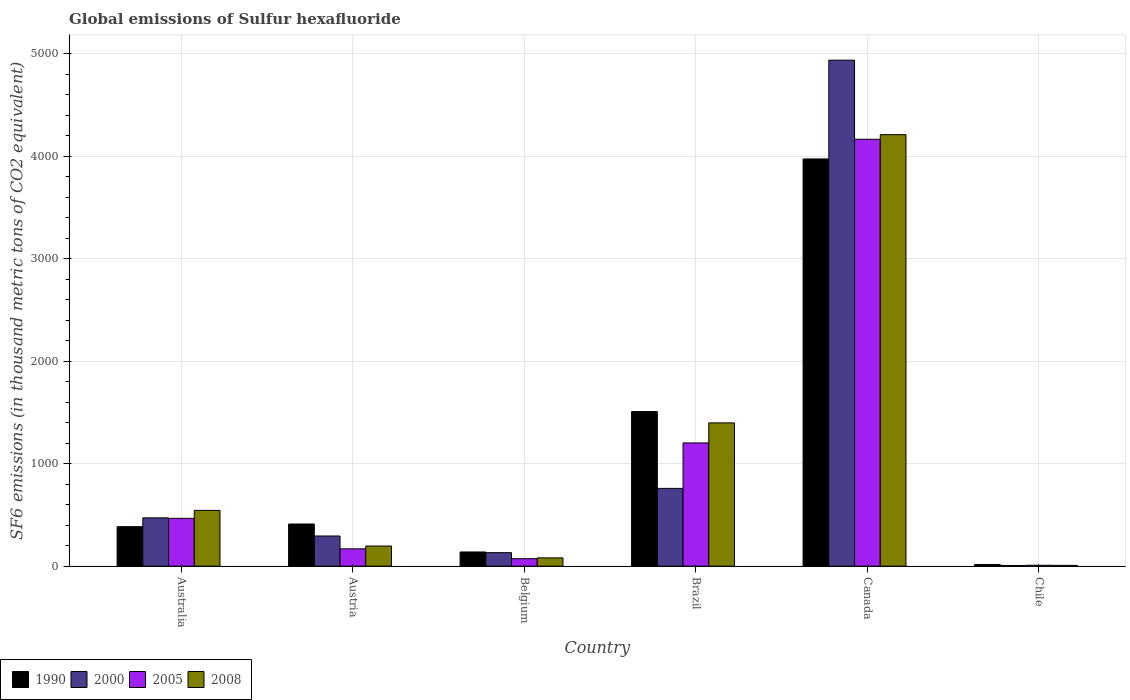How many groups of bars are there?
Offer a very short reply. 6. Are the number of bars per tick equal to the number of legend labels?
Your response must be concise. Yes. How many bars are there on the 6th tick from the left?
Make the answer very short. 4. How many bars are there on the 5th tick from the right?
Keep it short and to the point. 4. What is the label of the 1st group of bars from the left?
Provide a short and direct response. Australia. In how many cases, is the number of bars for a given country not equal to the number of legend labels?
Ensure brevity in your answer.  0. What is the global emissions of Sulfur hexafluoride in 2000 in Belgium?
Your response must be concise. 131.7. Across all countries, what is the maximum global emissions of Sulfur hexafluoride in 2008?
Give a very brief answer. 4208.8. In which country was the global emissions of Sulfur hexafluoride in 2008 maximum?
Provide a succinct answer. Canada. In which country was the global emissions of Sulfur hexafluoride in 2005 minimum?
Keep it short and to the point. Chile. What is the total global emissions of Sulfur hexafluoride in 2005 in the graph?
Your answer should be very brief. 6083.3. What is the difference between the global emissions of Sulfur hexafluoride in 1990 in Australia and that in Canada?
Provide a succinct answer. -3586.7. What is the difference between the global emissions of Sulfur hexafluoride in 1990 in Australia and the global emissions of Sulfur hexafluoride in 2000 in Chile?
Ensure brevity in your answer.  378.4. What is the average global emissions of Sulfur hexafluoride in 1990 per country?
Provide a succinct answer. 1071.83. What is the difference between the global emissions of Sulfur hexafluoride of/in 2008 and global emissions of Sulfur hexafluoride of/in 1990 in Brazil?
Give a very brief answer. -110.6. What is the ratio of the global emissions of Sulfur hexafluoride in 2000 in Australia to that in Brazil?
Offer a terse response. 0.62. What is the difference between the highest and the second highest global emissions of Sulfur hexafluoride in 1990?
Your response must be concise. 3560.6. What is the difference between the highest and the lowest global emissions of Sulfur hexafluoride in 2008?
Provide a succinct answer. 4200.9. In how many countries, is the global emissions of Sulfur hexafluoride in 2000 greater than the average global emissions of Sulfur hexafluoride in 2000 taken over all countries?
Your answer should be very brief. 1. Is it the case that in every country, the sum of the global emissions of Sulfur hexafluoride in 2008 and global emissions of Sulfur hexafluoride in 1990 is greater than the sum of global emissions of Sulfur hexafluoride in 2005 and global emissions of Sulfur hexafluoride in 2000?
Keep it short and to the point. No. What does the 4th bar from the right in Chile represents?
Your answer should be compact. 1990. How many bars are there?
Give a very brief answer. 24. Are all the bars in the graph horizontal?
Ensure brevity in your answer.  No. What is the difference between two consecutive major ticks on the Y-axis?
Offer a very short reply. 1000. Does the graph contain grids?
Your response must be concise. Yes. Where does the legend appear in the graph?
Your response must be concise. Bottom left. What is the title of the graph?
Keep it short and to the point. Global emissions of Sulfur hexafluoride. Does "1976" appear as one of the legend labels in the graph?
Make the answer very short. No. What is the label or title of the X-axis?
Ensure brevity in your answer.  Country. What is the label or title of the Y-axis?
Provide a succinct answer. SF6 emissions (in thousand metric tons of CO2 equivalent). What is the SF6 emissions (in thousand metric tons of CO2 equivalent) in 1990 in Australia?
Provide a short and direct response. 385.1. What is the SF6 emissions (in thousand metric tons of CO2 equivalent) in 2000 in Australia?
Your answer should be compact. 471.2. What is the SF6 emissions (in thousand metric tons of CO2 equivalent) of 2005 in Australia?
Offer a very short reply. 466.6. What is the SF6 emissions (in thousand metric tons of CO2 equivalent) of 2008 in Australia?
Your response must be concise. 544.1. What is the SF6 emissions (in thousand metric tons of CO2 equivalent) of 1990 in Austria?
Your response must be concise. 411.2. What is the SF6 emissions (in thousand metric tons of CO2 equivalent) in 2000 in Austria?
Your answer should be compact. 294.4. What is the SF6 emissions (in thousand metric tons of CO2 equivalent) of 2005 in Austria?
Your answer should be compact. 169. What is the SF6 emissions (in thousand metric tons of CO2 equivalent) of 2008 in Austria?
Keep it short and to the point. 196.4. What is the SF6 emissions (in thousand metric tons of CO2 equivalent) of 1990 in Belgium?
Keep it short and to the point. 138.5. What is the SF6 emissions (in thousand metric tons of CO2 equivalent) of 2000 in Belgium?
Give a very brief answer. 131.7. What is the SF6 emissions (in thousand metric tons of CO2 equivalent) of 2005 in Belgium?
Give a very brief answer. 72.9. What is the SF6 emissions (in thousand metric tons of CO2 equivalent) of 2008 in Belgium?
Your answer should be compact. 80.9. What is the SF6 emissions (in thousand metric tons of CO2 equivalent) of 1990 in Brazil?
Your answer should be very brief. 1507.9. What is the SF6 emissions (in thousand metric tons of CO2 equivalent) in 2000 in Brazil?
Your response must be concise. 758.7. What is the SF6 emissions (in thousand metric tons of CO2 equivalent) in 2005 in Brazil?
Keep it short and to the point. 1202. What is the SF6 emissions (in thousand metric tons of CO2 equivalent) in 2008 in Brazil?
Offer a terse response. 1397.3. What is the SF6 emissions (in thousand metric tons of CO2 equivalent) in 1990 in Canada?
Your answer should be very brief. 3971.8. What is the SF6 emissions (in thousand metric tons of CO2 equivalent) in 2000 in Canada?
Provide a succinct answer. 4935.1. What is the SF6 emissions (in thousand metric tons of CO2 equivalent) in 2005 in Canada?
Ensure brevity in your answer.  4163.8. What is the SF6 emissions (in thousand metric tons of CO2 equivalent) of 2008 in Canada?
Ensure brevity in your answer.  4208.8. What is the SF6 emissions (in thousand metric tons of CO2 equivalent) in 1990 in Chile?
Provide a succinct answer. 16.5. What is the SF6 emissions (in thousand metric tons of CO2 equivalent) of 2000 in Chile?
Your answer should be very brief. 6.7. Across all countries, what is the maximum SF6 emissions (in thousand metric tons of CO2 equivalent) of 1990?
Your answer should be very brief. 3971.8. Across all countries, what is the maximum SF6 emissions (in thousand metric tons of CO2 equivalent) of 2000?
Your response must be concise. 4935.1. Across all countries, what is the maximum SF6 emissions (in thousand metric tons of CO2 equivalent) of 2005?
Your answer should be compact. 4163.8. Across all countries, what is the maximum SF6 emissions (in thousand metric tons of CO2 equivalent) in 2008?
Keep it short and to the point. 4208.8. Across all countries, what is the minimum SF6 emissions (in thousand metric tons of CO2 equivalent) of 1990?
Provide a succinct answer. 16.5. Across all countries, what is the minimum SF6 emissions (in thousand metric tons of CO2 equivalent) of 2000?
Provide a succinct answer. 6.7. Across all countries, what is the minimum SF6 emissions (in thousand metric tons of CO2 equivalent) in 2005?
Provide a short and direct response. 9. What is the total SF6 emissions (in thousand metric tons of CO2 equivalent) in 1990 in the graph?
Make the answer very short. 6431. What is the total SF6 emissions (in thousand metric tons of CO2 equivalent) of 2000 in the graph?
Give a very brief answer. 6597.8. What is the total SF6 emissions (in thousand metric tons of CO2 equivalent) of 2005 in the graph?
Ensure brevity in your answer.  6083.3. What is the total SF6 emissions (in thousand metric tons of CO2 equivalent) of 2008 in the graph?
Your response must be concise. 6435.4. What is the difference between the SF6 emissions (in thousand metric tons of CO2 equivalent) in 1990 in Australia and that in Austria?
Ensure brevity in your answer.  -26.1. What is the difference between the SF6 emissions (in thousand metric tons of CO2 equivalent) of 2000 in Australia and that in Austria?
Keep it short and to the point. 176.8. What is the difference between the SF6 emissions (in thousand metric tons of CO2 equivalent) in 2005 in Australia and that in Austria?
Your answer should be compact. 297.6. What is the difference between the SF6 emissions (in thousand metric tons of CO2 equivalent) in 2008 in Australia and that in Austria?
Your response must be concise. 347.7. What is the difference between the SF6 emissions (in thousand metric tons of CO2 equivalent) in 1990 in Australia and that in Belgium?
Your answer should be very brief. 246.6. What is the difference between the SF6 emissions (in thousand metric tons of CO2 equivalent) in 2000 in Australia and that in Belgium?
Offer a terse response. 339.5. What is the difference between the SF6 emissions (in thousand metric tons of CO2 equivalent) of 2005 in Australia and that in Belgium?
Provide a succinct answer. 393.7. What is the difference between the SF6 emissions (in thousand metric tons of CO2 equivalent) in 2008 in Australia and that in Belgium?
Your answer should be compact. 463.2. What is the difference between the SF6 emissions (in thousand metric tons of CO2 equivalent) in 1990 in Australia and that in Brazil?
Make the answer very short. -1122.8. What is the difference between the SF6 emissions (in thousand metric tons of CO2 equivalent) in 2000 in Australia and that in Brazil?
Give a very brief answer. -287.5. What is the difference between the SF6 emissions (in thousand metric tons of CO2 equivalent) in 2005 in Australia and that in Brazil?
Keep it short and to the point. -735.4. What is the difference between the SF6 emissions (in thousand metric tons of CO2 equivalent) of 2008 in Australia and that in Brazil?
Your response must be concise. -853.2. What is the difference between the SF6 emissions (in thousand metric tons of CO2 equivalent) of 1990 in Australia and that in Canada?
Make the answer very short. -3586.7. What is the difference between the SF6 emissions (in thousand metric tons of CO2 equivalent) of 2000 in Australia and that in Canada?
Your answer should be very brief. -4463.9. What is the difference between the SF6 emissions (in thousand metric tons of CO2 equivalent) of 2005 in Australia and that in Canada?
Keep it short and to the point. -3697.2. What is the difference between the SF6 emissions (in thousand metric tons of CO2 equivalent) of 2008 in Australia and that in Canada?
Your answer should be compact. -3664.7. What is the difference between the SF6 emissions (in thousand metric tons of CO2 equivalent) of 1990 in Australia and that in Chile?
Make the answer very short. 368.6. What is the difference between the SF6 emissions (in thousand metric tons of CO2 equivalent) of 2000 in Australia and that in Chile?
Provide a short and direct response. 464.5. What is the difference between the SF6 emissions (in thousand metric tons of CO2 equivalent) in 2005 in Australia and that in Chile?
Your answer should be very brief. 457.6. What is the difference between the SF6 emissions (in thousand metric tons of CO2 equivalent) of 2008 in Australia and that in Chile?
Make the answer very short. 536.2. What is the difference between the SF6 emissions (in thousand metric tons of CO2 equivalent) in 1990 in Austria and that in Belgium?
Provide a succinct answer. 272.7. What is the difference between the SF6 emissions (in thousand metric tons of CO2 equivalent) in 2000 in Austria and that in Belgium?
Give a very brief answer. 162.7. What is the difference between the SF6 emissions (in thousand metric tons of CO2 equivalent) of 2005 in Austria and that in Belgium?
Your response must be concise. 96.1. What is the difference between the SF6 emissions (in thousand metric tons of CO2 equivalent) of 2008 in Austria and that in Belgium?
Your response must be concise. 115.5. What is the difference between the SF6 emissions (in thousand metric tons of CO2 equivalent) in 1990 in Austria and that in Brazil?
Offer a terse response. -1096.7. What is the difference between the SF6 emissions (in thousand metric tons of CO2 equivalent) of 2000 in Austria and that in Brazil?
Your response must be concise. -464.3. What is the difference between the SF6 emissions (in thousand metric tons of CO2 equivalent) of 2005 in Austria and that in Brazil?
Provide a short and direct response. -1033. What is the difference between the SF6 emissions (in thousand metric tons of CO2 equivalent) of 2008 in Austria and that in Brazil?
Ensure brevity in your answer.  -1200.9. What is the difference between the SF6 emissions (in thousand metric tons of CO2 equivalent) of 1990 in Austria and that in Canada?
Provide a succinct answer. -3560.6. What is the difference between the SF6 emissions (in thousand metric tons of CO2 equivalent) in 2000 in Austria and that in Canada?
Provide a succinct answer. -4640.7. What is the difference between the SF6 emissions (in thousand metric tons of CO2 equivalent) in 2005 in Austria and that in Canada?
Keep it short and to the point. -3994.8. What is the difference between the SF6 emissions (in thousand metric tons of CO2 equivalent) in 2008 in Austria and that in Canada?
Offer a very short reply. -4012.4. What is the difference between the SF6 emissions (in thousand metric tons of CO2 equivalent) of 1990 in Austria and that in Chile?
Provide a short and direct response. 394.7. What is the difference between the SF6 emissions (in thousand metric tons of CO2 equivalent) of 2000 in Austria and that in Chile?
Provide a short and direct response. 287.7. What is the difference between the SF6 emissions (in thousand metric tons of CO2 equivalent) in 2005 in Austria and that in Chile?
Offer a terse response. 160. What is the difference between the SF6 emissions (in thousand metric tons of CO2 equivalent) of 2008 in Austria and that in Chile?
Keep it short and to the point. 188.5. What is the difference between the SF6 emissions (in thousand metric tons of CO2 equivalent) in 1990 in Belgium and that in Brazil?
Give a very brief answer. -1369.4. What is the difference between the SF6 emissions (in thousand metric tons of CO2 equivalent) of 2000 in Belgium and that in Brazil?
Offer a terse response. -627. What is the difference between the SF6 emissions (in thousand metric tons of CO2 equivalent) in 2005 in Belgium and that in Brazil?
Offer a very short reply. -1129.1. What is the difference between the SF6 emissions (in thousand metric tons of CO2 equivalent) in 2008 in Belgium and that in Brazil?
Make the answer very short. -1316.4. What is the difference between the SF6 emissions (in thousand metric tons of CO2 equivalent) in 1990 in Belgium and that in Canada?
Offer a very short reply. -3833.3. What is the difference between the SF6 emissions (in thousand metric tons of CO2 equivalent) of 2000 in Belgium and that in Canada?
Keep it short and to the point. -4803.4. What is the difference between the SF6 emissions (in thousand metric tons of CO2 equivalent) of 2005 in Belgium and that in Canada?
Provide a succinct answer. -4090.9. What is the difference between the SF6 emissions (in thousand metric tons of CO2 equivalent) of 2008 in Belgium and that in Canada?
Provide a succinct answer. -4127.9. What is the difference between the SF6 emissions (in thousand metric tons of CO2 equivalent) of 1990 in Belgium and that in Chile?
Provide a short and direct response. 122. What is the difference between the SF6 emissions (in thousand metric tons of CO2 equivalent) of 2000 in Belgium and that in Chile?
Your response must be concise. 125. What is the difference between the SF6 emissions (in thousand metric tons of CO2 equivalent) in 2005 in Belgium and that in Chile?
Ensure brevity in your answer.  63.9. What is the difference between the SF6 emissions (in thousand metric tons of CO2 equivalent) in 2008 in Belgium and that in Chile?
Provide a short and direct response. 73. What is the difference between the SF6 emissions (in thousand metric tons of CO2 equivalent) in 1990 in Brazil and that in Canada?
Your answer should be very brief. -2463.9. What is the difference between the SF6 emissions (in thousand metric tons of CO2 equivalent) in 2000 in Brazil and that in Canada?
Provide a short and direct response. -4176.4. What is the difference between the SF6 emissions (in thousand metric tons of CO2 equivalent) in 2005 in Brazil and that in Canada?
Your response must be concise. -2961.8. What is the difference between the SF6 emissions (in thousand metric tons of CO2 equivalent) in 2008 in Brazil and that in Canada?
Offer a terse response. -2811.5. What is the difference between the SF6 emissions (in thousand metric tons of CO2 equivalent) in 1990 in Brazil and that in Chile?
Offer a very short reply. 1491.4. What is the difference between the SF6 emissions (in thousand metric tons of CO2 equivalent) of 2000 in Brazil and that in Chile?
Keep it short and to the point. 752. What is the difference between the SF6 emissions (in thousand metric tons of CO2 equivalent) of 2005 in Brazil and that in Chile?
Make the answer very short. 1193. What is the difference between the SF6 emissions (in thousand metric tons of CO2 equivalent) in 2008 in Brazil and that in Chile?
Give a very brief answer. 1389.4. What is the difference between the SF6 emissions (in thousand metric tons of CO2 equivalent) in 1990 in Canada and that in Chile?
Provide a short and direct response. 3955.3. What is the difference between the SF6 emissions (in thousand metric tons of CO2 equivalent) of 2000 in Canada and that in Chile?
Ensure brevity in your answer.  4928.4. What is the difference between the SF6 emissions (in thousand metric tons of CO2 equivalent) of 2005 in Canada and that in Chile?
Keep it short and to the point. 4154.8. What is the difference between the SF6 emissions (in thousand metric tons of CO2 equivalent) of 2008 in Canada and that in Chile?
Keep it short and to the point. 4200.9. What is the difference between the SF6 emissions (in thousand metric tons of CO2 equivalent) in 1990 in Australia and the SF6 emissions (in thousand metric tons of CO2 equivalent) in 2000 in Austria?
Keep it short and to the point. 90.7. What is the difference between the SF6 emissions (in thousand metric tons of CO2 equivalent) in 1990 in Australia and the SF6 emissions (in thousand metric tons of CO2 equivalent) in 2005 in Austria?
Your answer should be compact. 216.1. What is the difference between the SF6 emissions (in thousand metric tons of CO2 equivalent) in 1990 in Australia and the SF6 emissions (in thousand metric tons of CO2 equivalent) in 2008 in Austria?
Offer a very short reply. 188.7. What is the difference between the SF6 emissions (in thousand metric tons of CO2 equivalent) of 2000 in Australia and the SF6 emissions (in thousand metric tons of CO2 equivalent) of 2005 in Austria?
Give a very brief answer. 302.2. What is the difference between the SF6 emissions (in thousand metric tons of CO2 equivalent) of 2000 in Australia and the SF6 emissions (in thousand metric tons of CO2 equivalent) of 2008 in Austria?
Provide a short and direct response. 274.8. What is the difference between the SF6 emissions (in thousand metric tons of CO2 equivalent) of 2005 in Australia and the SF6 emissions (in thousand metric tons of CO2 equivalent) of 2008 in Austria?
Your answer should be very brief. 270.2. What is the difference between the SF6 emissions (in thousand metric tons of CO2 equivalent) in 1990 in Australia and the SF6 emissions (in thousand metric tons of CO2 equivalent) in 2000 in Belgium?
Your answer should be very brief. 253.4. What is the difference between the SF6 emissions (in thousand metric tons of CO2 equivalent) in 1990 in Australia and the SF6 emissions (in thousand metric tons of CO2 equivalent) in 2005 in Belgium?
Offer a very short reply. 312.2. What is the difference between the SF6 emissions (in thousand metric tons of CO2 equivalent) of 1990 in Australia and the SF6 emissions (in thousand metric tons of CO2 equivalent) of 2008 in Belgium?
Offer a terse response. 304.2. What is the difference between the SF6 emissions (in thousand metric tons of CO2 equivalent) of 2000 in Australia and the SF6 emissions (in thousand metric tons of CO2 equivalent) of 2005 in Belgium?
Your response must be concise. 398.3. What is the difference between the SF6 emissions (in thousand metric tons of CO2 equivalent) in 2000 in Australia and the SF6 emissions (in thousand metric tons of CO2 equivalent) in 2008 in Belgium?
Make the answer very short. 390.3. What is the difference between the SF6 emissions (in thousand metric tons of CO2 equivalent) of 2005 in Australia and the SF6 emissions (in thousand metric tons of CO2 equivalent) of 2008 in Belgium?
Provide a succinct answer. 385.7. What is the difference between the SF6 emissions (in thousand metric tons of CO2 equivalent) of 1990 in Australia and the SF6 emissions (in thousand metric tons of CO2 equivalent) of 2000 in Brazil?
Your answer should be very brief. -373.6. What is the difference between the SF6 emissions (in thousand metric tons of CO2 equivalent) of 1990 in Australia and the SF6 emissions (in thousand metric tons of CO2 equivalent) of 2005 in Brazil?
Your answer should be very brief. -816.9. What is the difference between the SF6 emissions (in thousand metric tons of CO2 equivalent) of 1990 in Australia and the SF6 emissions (in thousand metric tons of CO2 equivalent) of 2008 in Brazil?
Your response must be concise. -1012.2. What is the difference between the SF6 emissions (in thousand metric tons of CO2 equivalent) of 2000 in Australia and the SF6 emissions (in thousand metric tons of CO2 equivalent) of 2005 in Brazil?
Offer a terse response. -730.8. What is the difference between the SF6 emissions (in thousand metric tons of CO2 equivalent) in 2000 in Australia and the SF6 emissions (in thousand metric tons of CO2 equivalent) in 2008 in Brazil?
Your response must be concise. -926.1. What is the difference between the SF6 emissions (in thousand metric tons of CO2 equivalent) in 2005 in Australia and the SF6 emissions (in thousand metric tons of CO2 equivalent) in 2008 in Brazil?
Your response must be concise. -930.7. What is the difference between the SF6 emissions (in thousand metric tons of CO2 equivalent) in 1990 in Australia and the SF6 emissions (in thousand metric tons of CO2 equivalent) in 2000 in Canada?
Make the answer very short. -4550. What is the difference between the SF6 emissions (in thousand metric tons of CO2 equivalent) in 1990 in Australia and the SF6 emissions (in thousand metric tons of CO2 equivalent) in 2005 in Canada?
Give a very brief answer. -3778.7. What is the difference between the SF6 emissions (in thousand metric tons of CO2 equivalent) in 1990 in Australia and the SF6 emissions (in thousand metric tons of CO2 equivalent) in 2008 in Canada?
Provide a short and direct response. -3823.7. What is the difference between the SF6 emissions (in thousand metric tons of CO2 equivalent) of 2000 in Australia and the SF6 emissions (in thousand metric tons of CO2 equivalent) of 2005 in Canada?
Offer a very short reply. -3692.6. What is the difference between the SF6 emissions (in thousand metric tons of CO2 equivalent) in 2000 in Australia and the SF6 emissions (in thousand metric tons of CO2 equivalent) in 2008 in Canada?
Give a very brief answer. -3737.6. What is the difference between the SF6 emissions (in thousand metric tons of CO2 equivalent) of 2005 in Australia and the SF6 emissions (in thousand metric tons of CO2 equivalent) of 2008 in Canada?
Your answer should be compact. -3742.2. What is the difference between the SF6 emissions (in thousand metric tons of CO2 equivalent) of 1990 in Australia and the SF6 emissions (in thousand metric tons of CO2 equivalent) of 2000 in Chile?
Your response must be concise. 378.4. What is the difference between the SF6 emissions (in thousand metric tons of CO2 equivalent) in 1990 in Australia and the SF6 emissions (in thousand metric tons of CO2 equivalent) in 2005 in Chile?
Give a very brief answer. 376.1. What is the difference between the SF6 emissions (in thousand metric tons of CO2 equivalent) in 1990 in Australia and the SF6 emissions (in thousand metric tons of CO2 equivalent) in 2008 in Chile?
Ensure brevity in your answer.  377.2. What is the difference between the SF6 emissions (in thousand metric tons of CO2 equivalent) of 2000 in Australia and the SF6 emissions (in thousand metric tons of CO2 equivalent) of 2005 in Chile?
Offer a very short reply. 462.2. What is the difference between the SF6 emissions (in thousand metric tons of CO2 equivalent) of 2000 in Australia and the SF6 emissions (in thousand metric tons of CO2 equivalent) of 2008 in Chile?
Provide a short and direct response. 463.3. What is the difference between the SF6 emissions (in thousand metric tons of CO2 equivalent) of 2005 in Australia and the SF6 emissions (in thousand metric tons of CO2 equivalent) of 2008 in Chile?
Give a very brief answer. 458.7. What is the difference between the SF6 emissions (in thousand metric tons of CO2 equivalent) in 1990 in Austria and the SF6 emissions (in thousand metric tons of CO2 equivalent) in 2000 in Belgium?
Your answer should be very brief. 279.5. What is the difference between the SF6 emissions (in thousand metric tons of CO2 equivalent) of 1990 in Austria and the SF6 emissions (in thousand metric tons of CO2 equivalent) of 2005 in Belgium?
Your answer should be compact. 338.3. What is the difference between the SF6 emissions (in thousand metric tons of CO2 equivalent) of 1990 in Austria and the SF6 emissions (in thousand metric tons of CO2 equivalent) of 2008 in Belgium?
Your response must be concise. 330.3. What is the difference between the SF6 emissions (in thousand metric tons of CO2 equivalent) of 2000 in Austria and the SF6 emissions (in thousand metric tons of CO2 equivalent) of 2005 in Belgium?
Your answer should be compact. 221.5. What is the difference between the SF6 emissions (in thousand metric tons of CO2 equivalent) in 2000 in Austria and the SF6 emissions (in thousand metric tons of CO2 equivalent) in 2008 in Belgium?
Ensure brevity in your answer.  213.5. What is the difference between the SF6 emissions (in thousand metric tons of CO2 equivalent) in 2005 in Austria and the SF6 emissions (in thousand metric tons of CO2 equivalent) in 2008 in Belgium?
Provide a succinct answer. 88.1. What is the difference between the SF6 emissions (in thousand metric tons of CO2 equivalent) of 1990 in Austria and the SF6 emissions (in thousand metric tons of CO2 equivalent) of 2000 in Brazil?
Your answer should be very brief. -347.5. What is the difference between the SF6 emissions (in thousand metric tons of CO2 equivalent) of 1990 in Austria and the SF6 emissions (in thousand metric tons of CO2 equivalent) of 2005 in Brazil?
Your response must be concise. -790.8. What is the difference between the SF6 emissions (in thousand metric tons of CO2 equivalent) of 1990 in Austria and the SF6 emissions (in thousand metric tons of CO2 equivalent) of 2008 in Brazil?
Give a very brief answer. -986.1. What is the difference between the SF6 emissions (in thousand metric tons of CO2 equivalent) in 2000 in Austria and the SF6 emissions (in thousand metric tons of CO2 equivalent) in 2005 in Brazil?
Your answer should be very brief. -907.6. What is the difference between the SF6 emissions (in thousand metric tons of CO2 equivalent) in 2000 in Austria and the SF6 emissions (in thousand metric tons of CO2 equivalent) in 2008 in Brazil?
Keep it short and to the point. -1102.9. What is the difference between the SF6 emissions (in thousand metric tons of CO2 equivalent) of 2005 in Austria and the SF6 emissions (in thousand metric tons of CO2 equivalent) of 2008 in Brazil?
Make the answer very short. -1228.3. What is the difference between the SF6 emissions (in thousand metric tons of CO2 equivalent) of 1990 in Austria and the SF6 emissions (in thousand metric tons of CO2 equivalent) of 2000 in Canada?
Offer a terse response. -4523.9. What is the difference between the SF6 emissions (in thousand metric tons of CO2 equivalent) of 1990 in Austria and the SF6 emissions (in thousand metric tons of CO2 equivalent) of 2005 in Canada?
Your answer should be very brief. -3752.6. What is the difference between the SF6 emissions (in thousand metric tons of CO2 equivalent) of 1990 in Austria and the SF6 emissions (in thousand metric tons of CO2 equivalent) of 2008 in Canada?
Your answer should be very brief. -3797.6. What is the difference between the SF6 emissions (in thousand metric tons of CO2 equivalent) of 2000 in Austria and the SF6 emissions (in thousand metric tons of CO2 equivalent) of 2005 in Canada?
Your answer should be very brief. -3869.4. What is the difference between the SF6 emissions (in thousand metric tons of CO2 equivalent) in 2000 in Austria and the SF6 emissions (in thousand metric tons of CO2 equivalent) in 2008 in Canada?
Keep it short and to the point. -3914.4. What is the difference between the SF6 emissions (in thousand metric tons of CO2 equivalent) of 2005 in Austria and the SF6 emissions (in thousand metric tons of CO2 equivalent) of 2008 in Canada?
Offer a very short reply. -4039.8. What is the difference between the SF6 emissions (in thousand metric tons of CO2 equivalent) in 1990 in Austria and the SF6 emissions (in thousand metric tons of CO2 equivalent) in 2000 in Chile?
Your response must be concise. 404.5. What is the difference between the SF6 emissions (in thousand metric tons of CO2 equivalent) in 1990 in Austria and the SF6 emissions (in thousand metric tons of CO2 equivalent) in 2005 in Chile?
Your response must be concise. 402.2. What is the difference between the SF6 emissions (in thousand metric tons of CO2 equivalent) of 1990 in Austria and the SF6 emissions (in thousand metric tons of CO2 equivalent) of 2008 in Chile?
Your answer should be very brief. 403.3. What is the difference between the SF6 emissions (in thousand metric tons of CO2 equivalent) in 2000 in Austria and the SF6 emissions (in thousand metric tons of CO2 equivalent) in 2005 in Chile?
Provide a succinct answer. 285.4. What is the difference between the SF6 emissions (in thousand metric tons of CO2 equivalent) of 2000 in Austria and the SF6 emissions (in thousand metric tons of CO2 equivalent) of 2008 in Chile?
Provide a succinct answer. 286.5. What is the difference between the SF6 emissions (in thousand metric tons of CO2 equivalent) of 2005 in Austria and the SF6 emissions (in thousand metric tons of CO2 equivalent) of 2008 in Chile?
Your answer should be very brief. 161.1. What is the difference between the SF6 emissions (in thousand metric tons of CO2 equivalent) in 1990 in Belgium and the SF6 emissions (in thousand metric tons of CO2 equivalent) in 2000 in Brazil?
Provide a succinct answer. -620.2. What is the difference between the SF6 emissions (in thousand metric tons of CO2 equivalent) in 1990 in Belgium and the SF6 emissions (in thousand metric tons of CO2 equivalent) in 2005 in Brazil?
Offer a very short reply. -1063.5. What is the difference between the SF6 emissions (in thousand metric tons of CO2 equivalent) in 1990 in Belgium and the SF6 emissions (in thousand metric tons of CO2 equivalent) in 2008 in Brazil?
Offer a terse response. -1258.8. What is the difference between the SF6 emissions (in thousand metric tons of CO2 equivalent) of 2000 in Belgium and the SF6 emissions (in thousand metric tons of CO2 equivalent) of 2005 in Brazil?
Give a very brief answer. -1070.3. What is the difference between the SF6 emissions (in thousand metric tons of CO2 equivalent) in 2000 in Belgium and the SF6 emissions (in thousand metric tons of CO2 equivalent) in 2008 in Brazil?
Provide a succinct answer. -1265.6. What is the difference between the SF6 emissions (in thousand metric tons of CO2 equivalent) of 2005 in Belgium and the SF6 emissions (in thousand metric tons of CO2 equivalent) of 2008 in Brazil?
Give a very brief answer. -1324.4. What is the difference between the SF6 emissions (in thousand metric tons of CO2 equivalent) in 1990 in Belgium and the SF6 emissions (in thousand metric tons of CO2 equivalent) in 2000 in Canada?
Your answer should be compact. -4796.6. What is the difference between the SF6 emissions (in thousand metric tons of CO2 equivalent) of 1990 in Belgium and the SF6 emissions (in thousand metric tons of CO2 equivalent) of 2005 in Canada?
Keep it short and to the point. -4025.3. What is the difference between the SF6 emissions (in thousand metric tons of CO2 equivalent) of 1990 in Belgium and the SF6 emissions (in thousand metric tons of CO2 equivalent) of 2008 in Canada?
Keep it short and to the point. -4070.3. What is the difference between the SF6 emissions (in thousand metric tons of CO2 equivalent) of 2000 in Belgium and the SF6 emissions (in thousand metric tons of CO2 equivalent) of 2005 in Canada?
Your answer should be very brief. -4032.1. What is the difference between the SF6 emissions (in thousand metric tons of CO2 equivalent) of 2000 in Belgium and the SF6 emissions (in thousand metric tons of CO2 equivalent) of 2008 in Canada?
Ensure brevity in your answer.  -4077.1. What is the difference between the SF6 emissions (in thousand metric tons of CO2 equivalent) in 2005 in Belgium and the SF6 emissions (in thousand metric tons of CO2 equivalent) in 2008 in Canada?
Provide a short and direct response. -4135.9. What is the difference between the SF6 emissions (in thousand metric tons of CO2 equivalent) of 1990 in Belgium and the SF6 emissions (in thousand metric tons of CO2 equivalent) of 2000 in Chile?
Make the answer very short. 131.8. What is the difference between the SF6 emissions (in thousand metric tons of CO2 equivalent) in 1990 in Belgium and the SF6 emissions (in thousand metric tons of CO2 equivalent) in 2005 in Chile?
Ensure brevity in your answer.  129.5. What is the difference between the SF6 emissions (in thousand metric tons of CO2 equivalent) in 1990 in Belgium and the SF6 emissions (in thousand metric tons of CO2 equivalent) in 2008 in Chile?
Your answer should be very brief. 130.6. What is the difference between the SF6 emissions (in thousand metric tons of CO2 equivalent) in 2000 in Belgium and the SF6 emissions (in thousand metric tons of CO2 equivalent) in 2005 in Chile?
Provide a succinct answer. 122.7. What is the difference between the SF6 emissions (in thousand metric tons of CO2 equivalent) in 2000 in Belgium and the SF6 emissions (in thousand metric tons of CO2 equivalent) in 2008 in Chile?
Your answer should be very brief. 123.8. What is the difference between the SF6 emissions (in thousand metric tons of CO2 equivalent) in 2005 in Belgium and the SF6 emissions (in thousand metric tons of CO2 equivalent) in 2008 in Chile?
Give a very brief answer. 65. What is the difference between the SF6 emissions (in thousand metric tons of CO2 equivalent) in 1990 in Brazil and the SF6 emissions (in thousand metric tons of CO2 equivalent) in 2000 in Canada?
Your response must be concise. -3427.2. What is the difference between the SF6 emissions (in thousand metric tons of CO2 equivalent) of 1990 in Brazil and the SF6 emissions (in thousand metric tons of CO2 equivalent) of 2005 in Canada?
Offer a very short reply. -2655.9. What is the difference between the SF6 emissions (in thousand metric tons of CO2 equivalent) in 1990 in Brazil and the SF6 emissions (in thousand metric tons of CO2 equivalent) in 2008 in Canada?
Your answer should be very brief. -2700.9. What is the difference between the SF6 emissions (in thousand metric tons of CO2 equivalent) of 2000 in Brazil and the SF6 emissions (in thousand metric tons of CO2 equivalent) of 2005 in Canada?
Your response must be concise. -3405.1. What is the difference between the SF6 emissions (in thousand metric tons of CO2 equivalent) of 2000 in Brazil and the SF6 emissions (in thousand metric tons of CO2 equivalent) of 2008 in Canada?
Make the answer very short. -3450.1. What is the difference between the SF6 emissions (in thousand metric tons of CO2 equivalent) of 2005 in Brazil and the SF6 emissions (in thousand metric tons of CO2 equivalent) of 2008 in Canada?
Provide a succinct answer. -3006.8. What is the difference between the SF6 emissions (in thousand metric tons of CO2 equivalent) of 1990 in Brazil and the SF6 emissions (in thousand metric tons of CO2 equivalent) of 2000 in Chile?
Ensure brevity in your answer.  1501.2. What is the difference between the SF6 emissions (in thousand metric tons of CO2 equivalent) of 1990 in Brazil and the SF6 emissions (in thousand metric tons of CO2 equivalent) of 2005 in Chile?
Make the answer very short. 1498.9. What is the difference between the SF6 emissions (in thousand metric tons of CO2 equivalent) in 1990 in Brazil and the SF6 emissions (in thousand metric tons of CO2 equivalent) in 2008 in Chile?
Make the answer very short. 1500. What is the difference between the SF6 emissions (in thousand metric tons of CO2 equivalent) of 2000 in Brazil and the SF6 emissions (in thousand metric tons of CO2 equivalent) of 2005 in Chile?
Keep it short and to the point. 749.7. What is the difference between the SF6 emissions (in thousand metric tons of CO2 equivalent) of 2000 in Brazil and the SF6 emissions (in thousand metric tons of CO2 equivalent) of 2008 in Chile?
Ensure brevity in your answer.  750.8. What is the difference between the SF6 emissions (in thousand metric tons of CO2 equivalent) of 2005 in Brazil and the SF6 emissions (in thousand metric tons of CO2 equivalent) of 2008 in Chile?
Your answer should be compact. 1194.1. What is the difference between the SF6 emissions (in thousand metric tons of CO2 equivalent) in 1990 in Canada and the SF6 emissions (in thousand metric tons of CO2 equivalent) in 2000 in Chile?
Provide a succinct answer. 3965.1. What is the difference between the SF6 emissions (in thousand metric tons of CO2 equivalent) of 1990 in Canada and the SF6 emissions (in thousand metric tons of CO2 equivalent) of 2005 in Chile?
Provide a succinct answer. 3962.8. What is the difference between the SF6 emissions (in thousand metric tons of CO2 equivalent) of 1990 in Canada and the SF6 emissions (in thousand metric tons of CO2 equivalent) of 2008 in Chile?
Your answer should be very brief. 3963.9. What is the difference between the SF6 emissions (in thousand metric tons of CO2 equivalent) of 2000 in Canada and the SF6 emissions (in thousand metric tons of CO2 equivalent) of 2005 in Chile?
Provide a short and direct response. 4926.1. What is the difference between the SF6 emissions (in thousand metric tons of CO2 equivalent) in 2000 in Canada and the SF6 emissions (in thousand metric tons of CO2 equivalent) in 2008 in Chile?
Provide a succinct answer. 4927.2. What is the difference between the SF6 emissions (in thousand metric tons of CO2 equivalent) of 2005 in Canada and the SF6 emissions (in thousand metric tons of CO2 equivalent) of 2008 in Chile?
Make the answer very short. 4155.9. What is the average SF6 emissions (in thousand metric tons of CO2 equivalent) of 1990 per country?
Your answer should be very brief. 1071.83. What is the average SF6 emissions (in thousand metric tons of CO2 equivalent) in 2000 per country?
Provide a short and direct response. 1099.63. What is the average SF6 emissions (in thousand metric tons of CO2 equivalent) of 2005 per country?
Your answer should be compact. 1013.88. What is the average SF6 emissions (in thousand metric tons of CO2 equivalent) of 2008 per country?
Give a very brief answer. 1072.57. What is the difference between the SF6 emissions (in thousand metric tons of CO2 equivalent) of 1990 and SF6 emissions (in thousand metric tons of CO2 equivalent) of 2000 in Australia?
Ensure brevity in your answer.  -86.1. What is the difference between the SF6 emissions (in thousand metric tons of CO2 equivalent) in 1990 and SF6 emissions (in thousand metric tons of CO2 equivalent) in 2005 in Australia?
Provide a short and direct response. -81.5. What is the difference between the SF6 emissions (in thousand metric tons of CO2 equivalent) in 1990 and SF6 emissions (in thousand metric tons of CO2 equivalent) in 2008 in Australia?
Offer a terse response. -159. What is the difference between the SF6 emissions (in thousand metric tons of CO2 equivalent) of 2000 and SF6 emissions (in thousand metric tons of CO2 equivalent) of 2008 in Australia?
Your response must be concise. -72.9. What is the difference between the SF6 emissions (in thousand metric tons of CO2 equivalent) of 2005 and SF6 emissions (in thousand metric tons of CO2 equivalent) of 2008 in Australia?
Provide a succinct answer. -77.5. What is the difference between the SF6 emissions (in thousand metric tons of CO2 equivalent) of 1990 and SF6 emissions (in thousand metric tons of CO2 equivalent) of 2000 in Austria?
Give a very brief answer. 116.8. What is the difference between the SF6 emissions (in thousand metric tons of CO2 equivalent) of 1990 and SF6 emissions (in thousand metric tons of CO2 equivalent) of 2005 in Austria?
Your answer should be very brief. 242.2. What is the difference between the SF6 emissions (in thousand metric tons of CO2 equivalent) in 1990 and SF6 emissions (in thousand metric tons of CO2 equivalent) in 2008 in Austria?
Offer a very short reply. 214.8. What is the difference between the SF6 emissions (in thousand metric tons of CO2 equivalent) in 2000 and SF6 emissions (in thousand metric tons of CO2 equivalent) in 2005 in Austria?
Your response must be concise. 125.4. What is the difference between the SF6 emissions (in thousand metric tons of CO2 equivalent) of 2000 and SF6 emissions (in thousand metric tons of CO2 equivalent) of 2008 in Austria?
Make the answer very short. 98. What is the difference between the SF6 emissions (in thousand metric tons of CO2 equivalent) of 2005 and SF6 emissions (in thousand metric tons of CO2 equivalent) of 2008 in Austria?
Your answer should be compact. -27.4. What is the difference between the SF6 emissions (in thousand metric tons of CO2 equivalent) in 1990 and SF6 emissions (in thousand metric tons of CO2 equivalent) in 2000 in Belgium?
Make the answer very short. 6.8. What is the difference between the SF6 emissions (in thousand metric tons of CO2 equivalent) in 1990 and SF6 emissions (in thousand metric tons of CO2 equivalent) in 2005 in Belgium?
Make the answer very short. 65.6. What is the difference between the SF6 emissions (in thousand metric tons of CO2 equivalent) in 1990 and SF6 emissions (in thousand metric tons of CO2 equivalent) in 2008 in Belgium?
Your answer should be compact. 57.6. What is the difference between the SF6 emissions (in thousand metric tons of CO2 equivalent) of 2000 and SF6 emissions (in thousand metric tons of CO2 equivalent) of 2005 in Belgium?
Provide a short and direct response. 58.8. What is the difference between the SF6 emissions (in thousand metric tons of CO2 equivalent) of 2000 and SF6 emissions (in thousand metric tons of CO2 equivalent) of 2008 in Belgium?
Provide a succinct answer. 50.8. What is the difference between the SF6 emissions (in thousand metric tons of CO2 equivalent) in 1990 and SF6 emissions (in thousand metric tons of CO2 equivalent) in 2000 in Brazil?
Provide a succinct answer. 749.2. What is the difference between the SF6 emissions (in thousand metric tons of CO2 equivalent) of 1990 and SF6 emissions (in thousand metric tons of CO2 equivalent) of 2005 in Brazil?
Ensure brevity in your answer.  305.9. What is the difference between the SF6 emissions (in thousand metric tons of CO2 equivalent) of 1990 and SF6 emissions (in thousand metric tons of CO2 equivalent) of 2008 in Brazil?
Keep it short and to the point. 110.6. What is the difference between the SF6 emissions (in thousand metric tons of CO2 equivalent) of 2000 and SF6 emissions (in thousand metric tons of CO2 equivalent) of 2005 in Brazil?
Ensure brevity in your answer.  -443.3. What is the difference between the SF6 emissions (in thousand metric tons of CO2 equivalent) of 2000 and SF6 emissions (in thousand metric tons of CO2 equivalent) of 2008 in Brazil?
Provide a short and direct response. -638.6. What is the difference between the SF6 emissions (in thousand metric tons of CO2 equivalent) of 2005 and SF6 emissions (in thousand metric tons of CO2 equivalent) of 2008 in Brazil?
Offer a terse response. -195.3. What is the difference between the SF6 emissions (in thousand metric tons of CO2 equivalent) of 1990 and SF6 emissions (in thousand metric tons of CO2 equivalent) of 2000 in Canada?
Offer a very short reply. -963.3. What is the difference between the SF6 emissions (in thousand metric tons of CO2 equivalent) of 1990 and SF6 emissions (in thousand metric tons of CO2 equivalent) of 2005 in Canada?
Your answer should be very brief. -192. What is the difference between the SF6 emissions (in thousand metric tons of CO2 equivalent) of 1990 and SF6 emissions (in thousand metric tons of CO2 equivalent) of 2008 in Canada?
Offer a terse response. -237. What is the difference between the SF6 emissions (in thousand metric tons of CO2 equivalent) of 2000 and SF6 emissions (in thousand metric tons of CO2 equivalent) of 2005 in Canada?
Your answer should be very brief. 771.3. What is the difference between the SF6 emissions (in thousand metric tons of CO2 equivalent) of 2000 and SF6 emissions (in thousand metric tons of CO2 equivalent) of 2008 in Canada?
Offer a terse response. 726.3. What is the difference between the SF6 emissions (in thousand metric tons of CO2 equivalent) in 2005 and SF6 emissions (in thousand metric tons of CO2 equivalent) in 2008 in Canada?
Provide a short and direct response. -45. What is the difference between the SF6 emissions (in thousand metric tons of CO2 equivalent) of 1990 and SF6 emissions (in thousand metric tons of CO2 equivalent) of 2005 in Chile?
Keep it short and to the point. 7.5. What is the difference between the SF6 emissions (in thousand metric tons of CO2 equivalent) of 1990 and SF6 emissions (in thousand metric tons of CO2 equivalent) of 2008 in Chile?
Make the answer very short. 8.6. What is the difference between the SF6 emissions (in thousand metric tons of CO2 equivalent) in 2005 and SF6 emissions (in thousand metric tons of CO2 equivalent) in 2008 in Chile?
Ensure brevity in your answer.  1.1. What is the ratio of the SF6 emissions (in thousand metric tons of CO2 equivalent) in 1990 in Australia to that in Austria?
Provide a succinct answer. 0.94. What is the ratio of the SF6 emissions (in thousand metric tons of CO2 equivalent) of 2000 in Australia to that in Austria?
Provide a succinct answer. 1.6. What is the ratio of the SF6 emissions (in thousand metric tons of CO2 equivalent) in 2005 in Australia to that in Austria?
Your answer should be compact. 2.76. What is the ratio of the SF6 emissions (in thousand metric tons of CO2 equivalent) of 2008 in Australia to that in Austria?
Offer a very short reply. 2.77. What is the ratio of the SF6 emissions (in thousand metric tons of CO2 equivalent) of 1990 in Australia to that in Belgium?
Your response must be concise. 2.78. What is the ratio of the SF6 emissions (in thousand metric tons of CO2 equivalent) in 2000 in Australia to that in Belgium?
Provide a short and direct response. 3.58. What is the ratio of the SF6 emissions (in thousand metric tons of CO2 equivalent) in 2005 in Australia to that in Belgium?
Your response must be concise. 6.4. What is the ratio of the SF6 emissions (in thousand metric tons of CO2 equivalent) of 2008 in Australia to that in Belgium?
Ensure brevity in your answer.  6.73. What is the ratio of the SF6 emissions (in thousand metric tons of CO2 equivalent) in 1990 in Australia to that in Brazil?
Your answer should be very brief. 0.26. What is the ratio of the SF6 emissions (in thousand metric tons of CO2 equivalent) of 2000 in Australia to that in Brazil?
Give a very brief answer. 0.62. What is the ratio of the SF6 emissions (in thousand metric tons of CO2 equivalent) in 2005 in Australia to that in Brazil?
Your answer should be very brief. 0.39. What is the ratio of the SF6 emissions (in thousand metric tons of CO2 equivalent) in 2008 in Australia to that in Brazil?
Give a very brief answer. 0.39. What is the ratio of the SF6 emissions (in thousand metric tons of CO2 equivalent) in 1990 in Australia to that in Canada?
Give a very brief answer. 0.1. What is the ratio of the SF6 emissions (in thousand metric tons of CO2 equivalent) in 2000 in Australia to that in Canada?
Give a very brief answer. 0.1. What is the ratio of the SF6 emissions (in thousand metric tons of CO2 equivalent) of 2005 in Australia to that in Canada?
Ensure brevity in your answer.  0.11. What is the ratio of the SF6 emissions (in thousand metric tons of CO2 equivalent) in 2008 in Australia to that in Canada?
Offer a terse response. 0.13. What is the ratio of the SF6 emissions (in thousand metric tons of CO2 equivalent) in 1990 in Australia to that in Chile?
Your answer should be very brief. 23.34. What is the ratio of the SF6 emissions (in thousand metric tons of CO2 equivalent) in 2000 in Australia to that in Chile?
Your answer should be very brief. 70.33. What is the ratio of the SF6 emissions (in thousand metric tons of CO2 equivalent) in 2005 in Australia to that in Chile?
Provide a succinct answer. 51.84. What is the ratio of the SF6 emissions (in thousand metric tons of CO2 equivalent) in 2008 in Australia to that in Chile?
Offer a very short reply. 68.87. What is the ratio of the SF6 emissions (in thousand metric tons of CO2 equivalent) of 1990 in Austria to that in Belgium?
Your answer should be very brief. 2.97. What is the ratio of the SF6 emissions (in thousand metric tons of CO2 equivalent) of 2000 in Austria to that in Belgium?
Your answer should be very brief. 2.24. What is the ratio of the SF6 emissions (in thousand metric tons of CO2 equivalent) in 2005 in Austria to that in Belgium?
Give a very brief answer. 2.32. What is the ratio of the SF6 emissions (in thousand metric tons of CO2 equivalent) of 2008 in Austria to that in Belgium?
Make the answer very short. 2.43. What is the ratio of the SF6 emissions (in thousand metric tons of CO2 equivalent) of 1990 in Austria to that in Brazil?
Offer a very short reply. 0.27. What is the ratio of the SF6 emissions (in thousand metric tons of CO2 equivalent) of 2000 in Austria to that in Brazil?
Offer a terse response. 0.39. What is the ratio of the SF6 emissions (in thousand metric tons of CO2 equivalent) in 2005 in Austria to that in Brazil?
Offer a very short reply. 0.14. What is the ratio of the SF6 emissions (in thousand metric tons of CO2 equivalent) of 2008 in Austria to that in Brazil?
Ensure brevity in your answer.  0.14. What is the ratio of the SF6 emissions (in thousand metric tons of CO2 equivalent) in 1990 in Austria to that in Canada?
Ensure brevity in your answer.  0.1. What is the ratio of the SF6 emissions (in thousand metric tons of CO2 equivalent) of 2000 in Austria to that in Canada?
Make the answer very short. 0.06. What is the ratio of the SF6 emissions (in thousand metric tons of CO2 equivalent) of 2005 in Austria to that in Canada?
Ensure brevity in your answer.  0.04. What is the ratio of the SF6 emissions (in thousand metric tons of CO2 equivalent) of 2008 in Austria to that in Canada?
Your answer should be very brief. 0.05. What is the ratio of the SF6 emissions (in thousand metric tons of CO2 equivalent) in 1990 in Austria to that in Chile?
Offer a very short reply. 24.92. What is the ratio of the SF6 emissions (in thousand metric tons of CO2 equivalent) in 2000 in Austria to that in Chile?
Your response must be concise. 43.94. What is the ratio of the SF6 emissions (in thousand metric tons of CO2 equivalent) in 2005 in Austria to that in Chile?
Offer a very short reply. 18.78. What is the ratio of the SF6 emissions (in thousand metric tons of CO2 equivalent) of 2008 in Austria to that in Chile?
Offer a very short reply. 24.86. What is the ratio of the SF6 emissions (in thousand metric tons of CO2 equivalent) in 1990 in Belgium to that in Brazil?
Offer a terse response. 0.09. What is the ratio of the SF6 emissions (in thousand metric tons of CO2 equivalent) of 2000 in Belgium to that in Brazil?
Offer a very short reply. 0.17. What is the ratio of the SF6 emissions (in thousand metric tons of CO2 equivalent) of 2005 in Belgium to that in Brazil?
Offer a terse response. 0.06. What is the ratio of the SF6 emissions (in thousand metric tons of CO2 equivalent) in 2008 in Belgium to that in Brazil?
Offer a terse response. 0.06. What is the ratio of the SF6 emissions (in thousand metric tons of CO2 equivalent) of 1990 in Belgium to that in Canada?
Offer a very short reply. 0.03. What is the ratio of the SF6 emissions (in thousand metric tons of CO2 equivalent) of 2000 in Belgium to that in Canada?
Your answer should be compact. 0.03. What is the ratio of the SF6 emissions (in thousand metric tons of CO2 equivalent) in 2005 in Belgium to that in Canada?
Your response must be concise. 0.02. What is the ratio of the SF6 emissions (in thousand metric tons of CO2 equivalent) of 2008 in Belgium to that in Canada?
Offer a very short reply. 0.02. What is the ratio of the SF6 emissions (in thousand metric tons of CO2 equivalent) in 1990 in Belgium to that in Chile?
Provide a succinct answer. 8.39. What is the ratio of the SF6 emissions (in thousand metric tons of CO2 equivalent) in 2000 in Belgium to that in Chile?
Offer a terse response. 19.66. What is the ratio of the SF6 emissions (in thousand metric tons of CO2 equivalent) of 2008 in Belgium to that in Chile?
Make the answer very short. 10.24. What is the ratio of the SF6 emissions (in thousand metric tons of CO2 equivalent) in 1990 in Brazil to that in Canada?
Give a very brief answer. 0.38. What is the ratio of the SF6 emissions (in thousand metric tons of CO2 equivalent) in 2000 in Brazil to that in Canada?
Give a very brief answer. 0.15. What is the ratio of the SF6 emissions (in thousand metric tons of CO2 equivalent) of 2005 in Brazil to that in Canada?
Offer a very short reply. 0.29. What is the ratio of the SF6 emissions (in thousand metric tons of CO2 equivalent) of 2008 in Brazil to that in Canada?
Ensure brevity in your answer.  0.33. What is the ratio of the SF6 emissions (in thousand metric tons of CO2 equivalent) in 1990 in Brazil to that in Chile?
Give a very brief answer. 91.39. What is the ratio of the SF6 emissions (in thousand metric tons of CO2 equivalent) in 2000 in Brazil to that in Chile?
Make the answer very short. 113.24. What is the ratio of the SF6 emissions (in thousand metric tons of CO2 equivalent) in 2005 in Brazil to that in Chile?
Keep it short and to the point. 133.56. What is the ratio of the SF6 emissions (in thousand metric tons of CO2 equivalent) of 2008 in Brazil to that in Chile?
Provide a short and direct response. 176.87. What is the ratio of the SF6 emissions (in thousand metric tons of CO2 equivalent) of 1990 in Canada to that in Chile?
Your answer should be very brief. 240.72. What is the ratio of the SF6 emissions (in thousand metric tons of CO2 equivalent) of 2000 in Canada to that in Chile?
Provide a short and direct response. 736.58. What is the ratio of the SF6 emissions (in thousand metric tons of CO2 equivalent) of 2005 in Canada to that in Chile?
Keep it short and to the point. 462.64. What is the ratio of the SF6 emissions (in thousand metric tons of CO2 equivalent) of 2008 in Canada to that in Chile?
Keep it short and to the point. 532.76. What is the difference between the highest and the second highest SF6 emissions (in thousand metric tons of CO2 equivalent) in 1990?
Make the answer very short. 2463.9. What is the difference between the highest and the second highest SF6 emissions (in thousand metric tons of CO2 equivalent) of 2000?
Keep it short and to the point. 4176.4. What is the difference between the highest and the second highest SF6 emissions (in thousand metric tons of CO2 equivalent) of 2005?
Keep it short and to the point. 2961.8. What is the difference between the highest and the second highest SF6 emissions (in thousand metric tons of CO2 equivalent) of 2008?
Provide a succinct answer. 2811.5. What is the difference between the highest and the lowest SF6 emissions (in thousand metric tons of CO2 equivalent) of 1990?
Provide a succinct answer. 3955.3. What is the difference between the highest and the lowest SF6 emissions (in thousand metric tons of CO2 equivalent) of 2000?
Give a very brief answer. 4928.4. What is the difference between the highest and the lowest SF6 emissions (in thousand metric tons of CO2 equivalent) of 2005?
Ensure brevity in your answer.  4154.8. What is the difference between the highest and the lowest SF6 emissions (in thousand metric tons of CO2 equivalent) of 2008?
Give a very brief answer. 4200.9. 